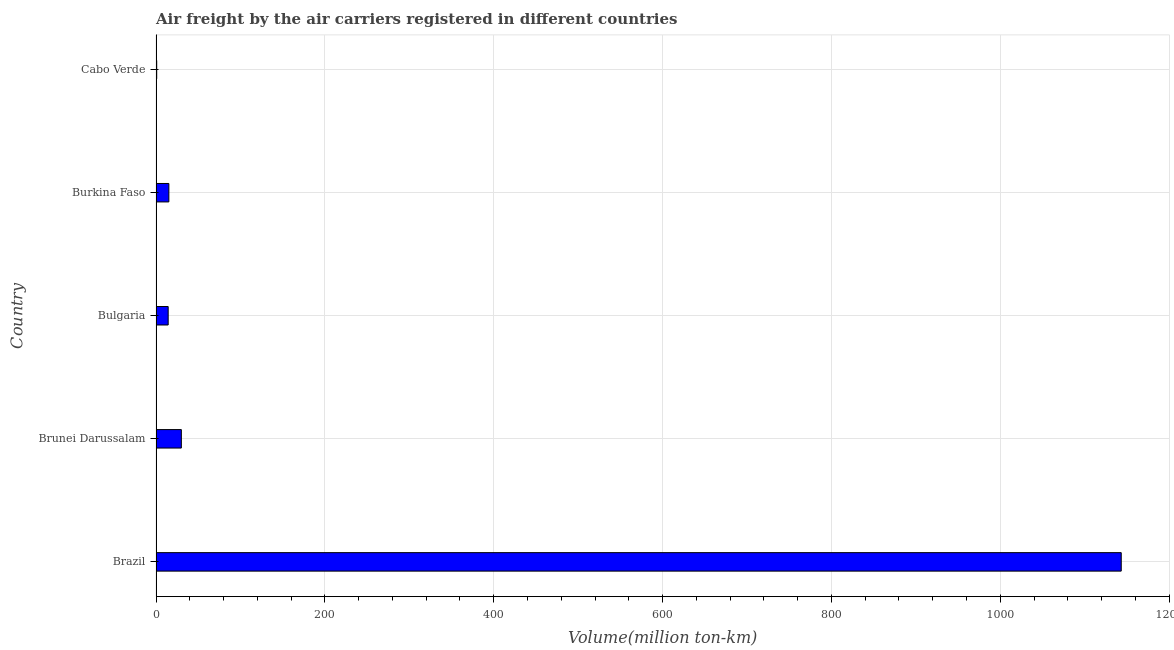Does the graph contain any zero values?
Ensure brevity in your answer.  No. Does the graph contain grids?
Provide a short and direct response. Yes. What is the title of the graph?
Your response must be concise. Air freight by the air carriers registered in different countries. What is the label or title of the X-axis?
Your answer should be very brief. Volume(million ton-km). What is the label or title of the Y-axis?
Your answer should be very brief. Country. What is the air freight in Cabo Verde?
Keep it short and to the point. 0.8. Across all countries, what is the maximum air freight?
Ensure brevity in your answer.  1143.3. Across all countries, what is the minimum air freight?
Provide a short and direct response. 0.8. In which country was the air freight maximum?
Keep it short and to the point. Brazil. In which country was the air freight minimum?
Keep it short and to the point. Cabo Verde. What is the sum of the air freight?
Keep it short and to the point. 1203.7. What is the difference between the air freight in Bulgaria and Cabo Verde?
Your response must be concise. 13.6. What is the average air freight per country?
Your answer should be very brief. 240.74. What is the median air freight?
Give a very brief answer. 15.2. What is the ratio of the air freight in Bulgaria to that in Burkina Faso?
Offer a terse response. 0.95. Is the air freight in Burkina Faso less than that in Cabo Verde?
Offer a terse response. No. What is the difference between the highest and the second highest air freight?
Make the answer very short. 1113.3. What is the difference between the highest and the lowest air freight?
Ensure brevity in your answer.  1142.5. Are all the bars in the graph horizontal?
Your response must be concise. Yes. What is the Volume(million ton-km) of Brazil?
Your answer should be very brief. 1143.3. What is the Volume(million ton-km) in Bulgaria?
Make the answer very short. 14.4. What is the Volume(million ton-km) of Burkina Faso?
Give a very brief answer. 15.2. What is the Volume(million ton-km) in Cabo Verde?
Your answer should be compact. 0.8. What is the difference between the Volume(million ton-km) in Brazil and Brunei Darussalam?
Give a very brief answer. 1113.3. What is the difference between the Volume(million ton-km) in Brazil and Bulgaria?
Provide a succinct answer. 1128.9. What is the difference between the Volume(million ton-km) in Brazil and Burkina Faso?
Make the answer very short. 1128.1. What is the difference between the Volume(million ton-km) in Brazil and Cabo Verde?
Your answer should be compact. 1142.5. What is the difference between the Volume(million ton-km) in Brunei Darussalam and Cabo Verde?
Your answer should be very brief. 29.2. What is the difference between the Volume(million ton-km) in Bulgaria and Burkina Faso?
Offer a very short reply. -0.8. What is the ratio of the Volume(million ton-km) in Brazil to that in Brunei Darussalam?
Your response must be concise. 38.11. What is the ratio of the Volume(million ton-km) in Brazil to that in Bulgaria?
Your response must be concise. 79.4. What is the ratio of the Volume(million ton-km) in Brazil to that in Burkina Faso?
Your response must be concise. 75.22. What is the ratio of the Volume(million ton-km) in Brazil to that in Cabo Verde?
Your response must be concise. 1429.12. What is the ratio of the Volume(million ton-km) in Brunei Darussalam to that in Bulgaria?
Keep it short and to the point. 2.08. What is the ratio of the Volume(million ton-km) in Brunei Darussalam to that in Burkina Faso?
Your answer should be compact. 1.97. What is the ratio of the Volume(million ton-km) in Brunei Darussalam to that in Cabo Verde?
Keep it short and to the point. 37.5. What is the ratio of the Volume(million ton-km) in Bulgaria to that in Burkina Faso?
Provide a succinct answer. 0.95. 